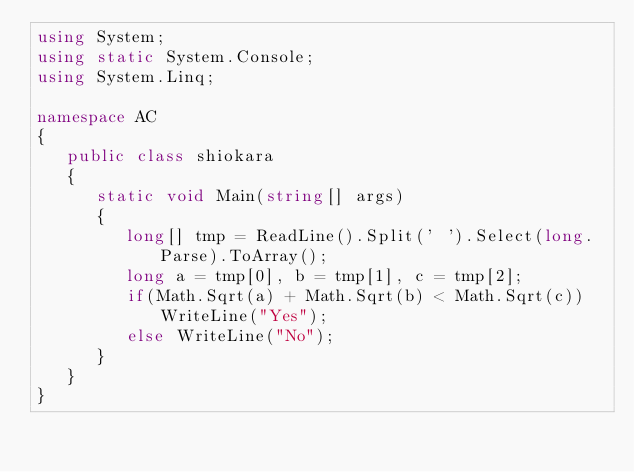Convert code to text. <code><loc_0><loc_0><loc_500><loc_500><_C#_>using System;
using static System.Console;
using System.Linq;

namespace AC
{
   public class shiokara
   {
      static void Main(string[] args)
      {
         long[] tmp = ReadLine().Split(' ').Select(long.Parse).ToArray();
         long a = tmp[0], b = tmp[1], c = tmp[2];
         if(Math.Sqrt(a) + Math.Sqrt(b) < Math.Sqrt(c)) WriteLine("Yes");
         else WriteLine("No");
      }
   }
}</code> 